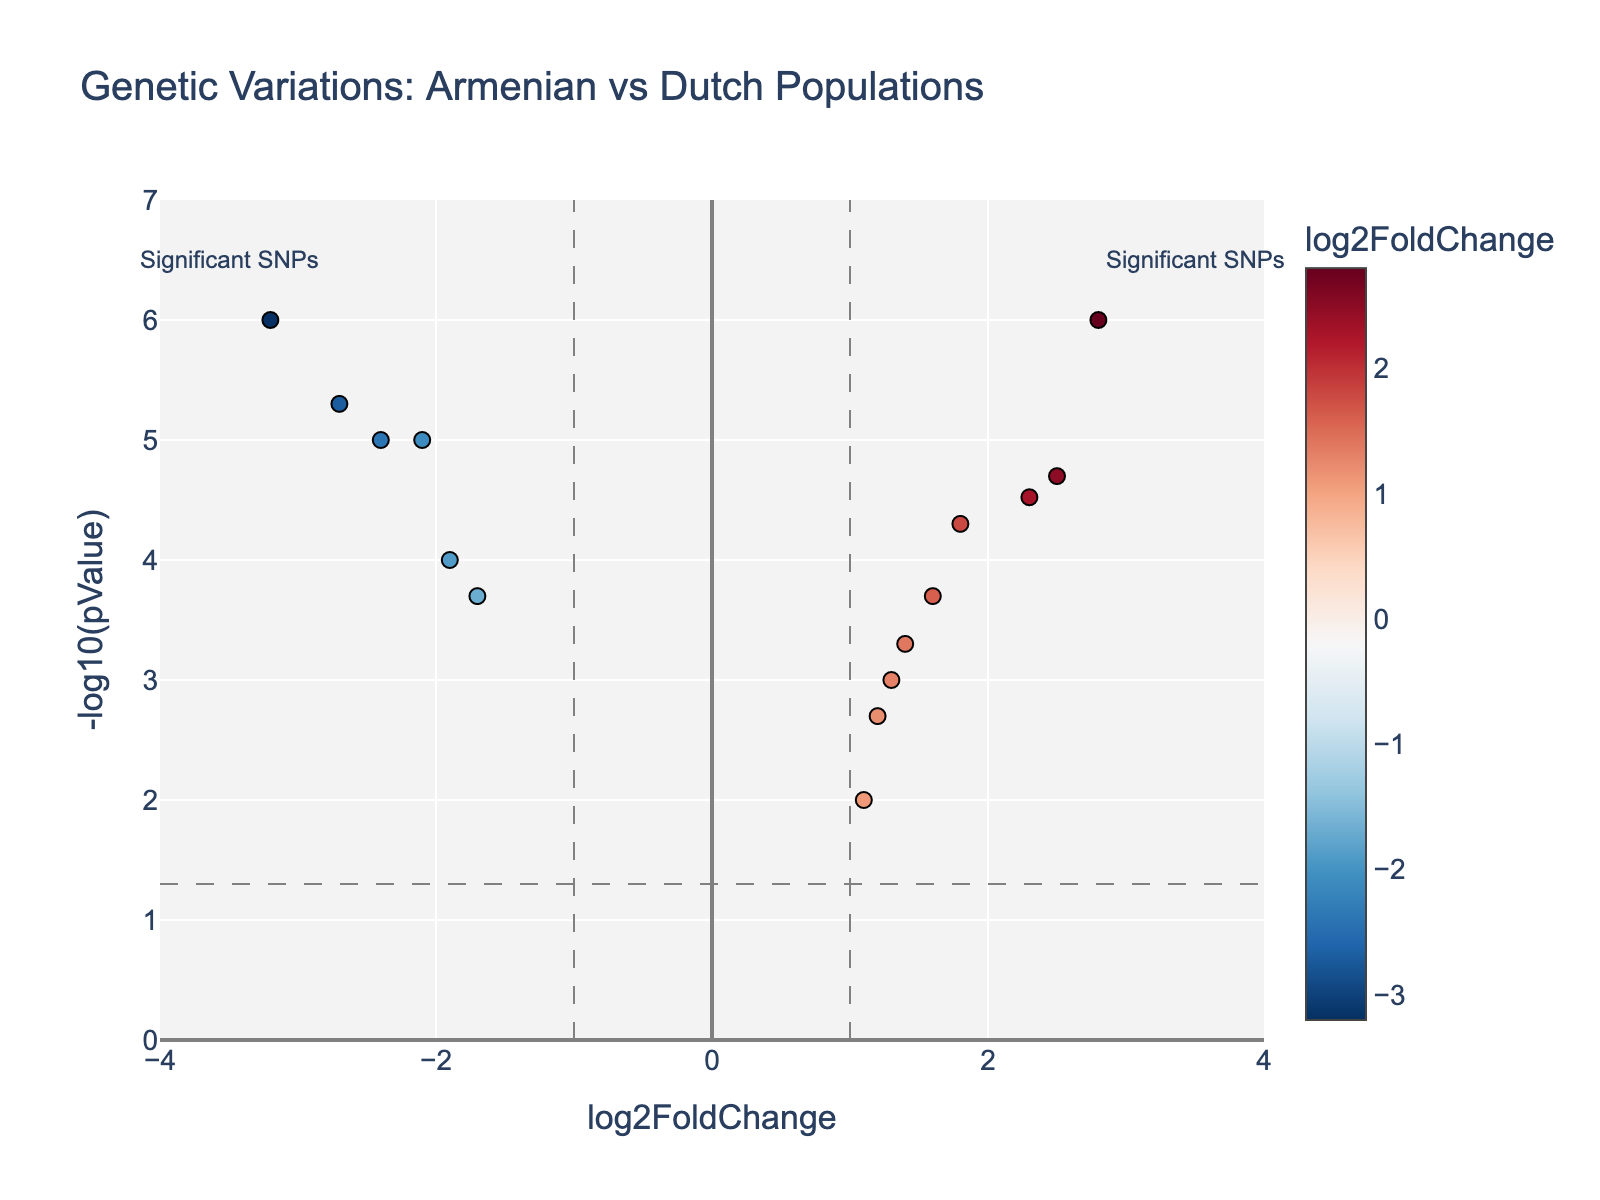What is the title of the figure? The title is usually displayed at the top of the figure. In this case, the title is clearly stated.
Answer: Genetic Variations: Armenian vs Dutch Populations What is displayed on the x-axis? The x-axis is labeled, indicating what kind of information it represents.
Answer: log2FoldChange What is displayed on the y-axis? The y-axis is labeled, indicating what kind of information it represents.
Answer: -log10(pValue) How many SNPs have a log2FoldChange greater than 2? Look at the x-axis and count the points that are positioned to the right of 2. There are two such points, including rs1426654 and rs4988235.
Answer: 2 What is the most significant SNP (lowest p-value)? The most significant SNP will be the one with the highest value on the y-axis, indicating a very low p-value. The SNP rs16891982 is positioned highest on the y-axis around -3.2 log2FoldChange.
Answer: rs16891982 How many SNPs are considered significant with a p-value threshold of 0.05? Convert the p-value threshold 0.05 to -log10(pValue) which is approximately 1.3 and count the number of points above this threshold line. There are ten SNPs above the line.
Answer: 10 Which SNP has the highest log2FoldChange? Identify the SNP positioned furthest to the right, which is rs4988235 with a log2FoldChange of about 2.8.
Answer: rs4988235 Which SNP has the lowest log2FoldChange? Identify the SNP positioned furthest to the left, which is rs16891982 with a log2FoldChange of about -3.2.
Answer: rs16891982 How many SNPs have a log2FoldChange between -2 and 2? Look at the region between -2 and 2 on the x-axis and count the points within this range. There are seven such points.
Answer: 7 